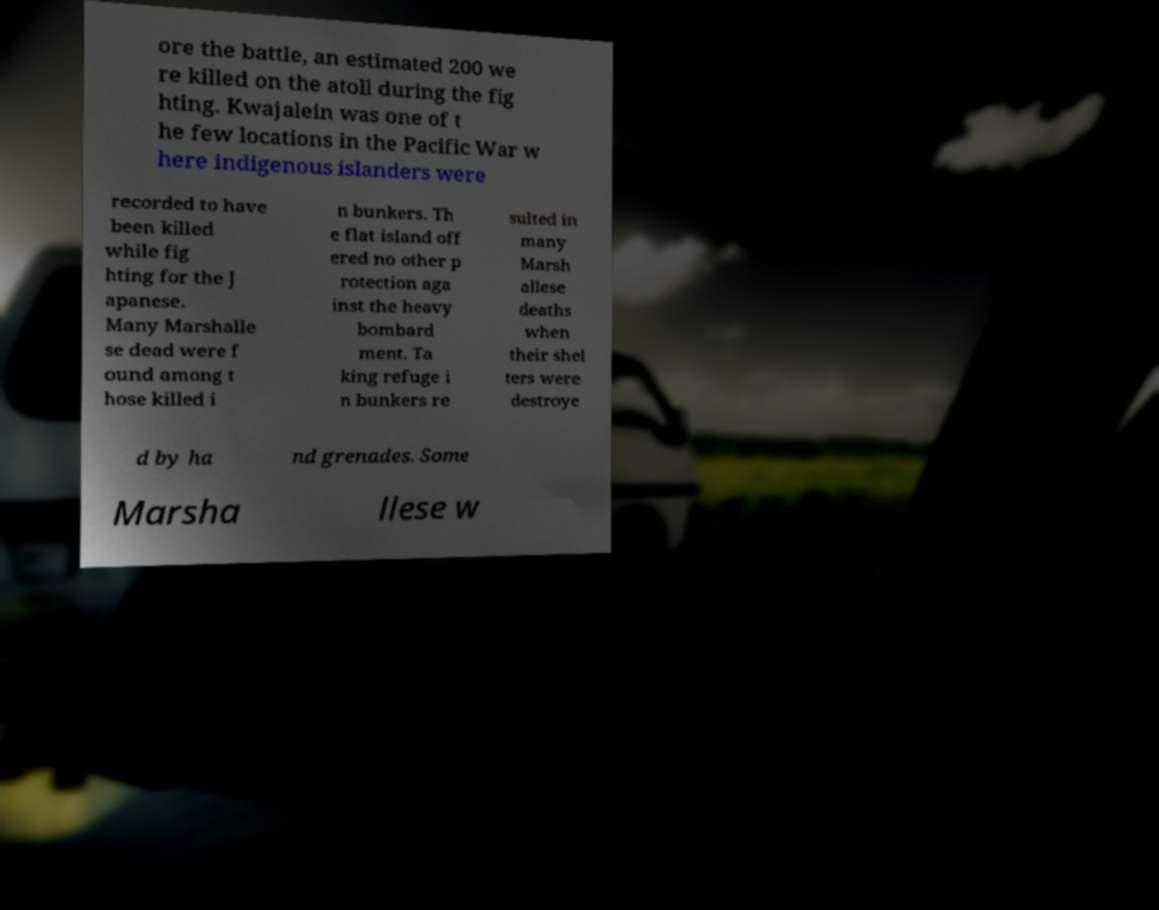There's text embedded in this image that I need extracted. Can you transcribe it verbatim? ore the battle, an estimated 200 we re killed on the atoll during the fig hting. Kwajalein was one of t he few locations in the Pacific War w here indigenous islanders were recorded to have been killed while fig hting for the J apanese. Many Marshalle se dead were f ound among t hose killed i n bunkers. Th e flat island off ered no other p rotection aga inst the heavy bombard ment. Ta king refuge i n bunkers re sulted in many Marsh allese deaths when their shel ters were destroye d by ha nd grenades. Some Marsha llese w 